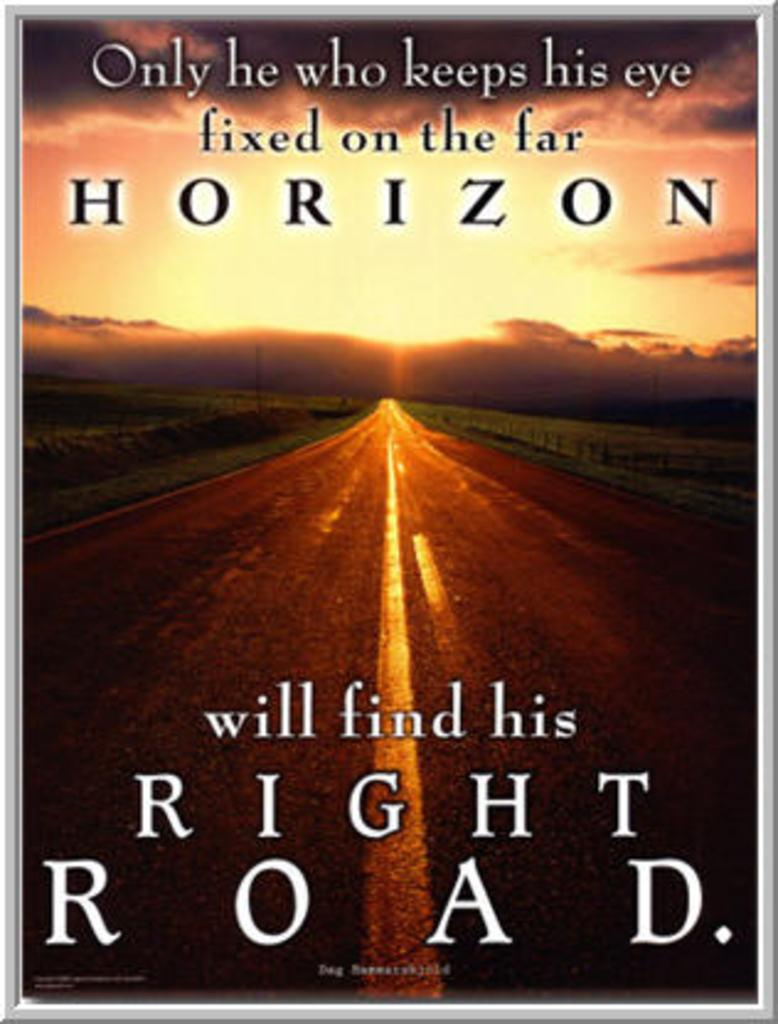What is the main subject of the image? The main subject of the image is the cover page of a book. What can be seen on the cover page? There is text on the cover page. Can you see any ear-shaped objects on the cover page of the book? There are no ear-shaped objects visible on the cover page of the book. Is there a fireman depicted on the cover page of the book? There is no fireman depicted on the cover page of the book. 